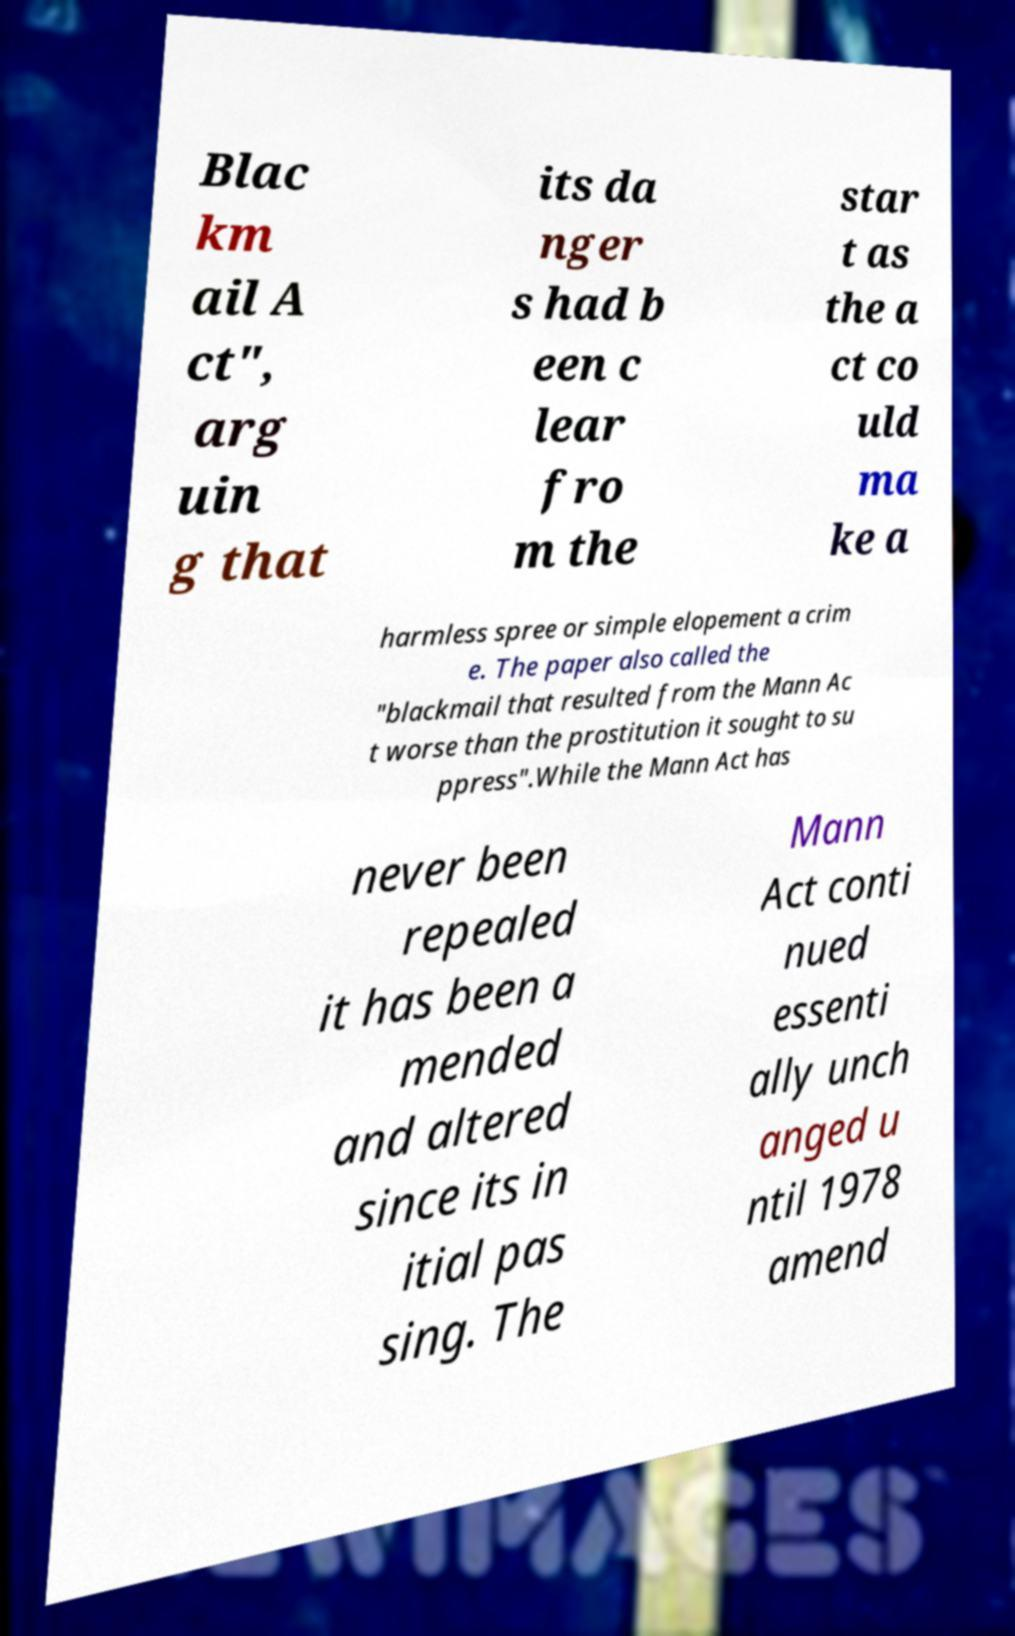Please read and relay the text visible in this image. What does it say? Blac km ail A ct", arg uin g that its da nger s had b een c lear fro m the star t as the a ct co uld ma ke a harmless spree or simple elopement a crim e. The paper also called the "blackmail that resulted from the Mann Ac t worse than the prostitution it sought to su ppress".While the Mann Act has never been repealed it has been a mended and altered since its in itial pas sing. The Mann Act conti nued essenti ally unch anged u ntil 1978 amend 